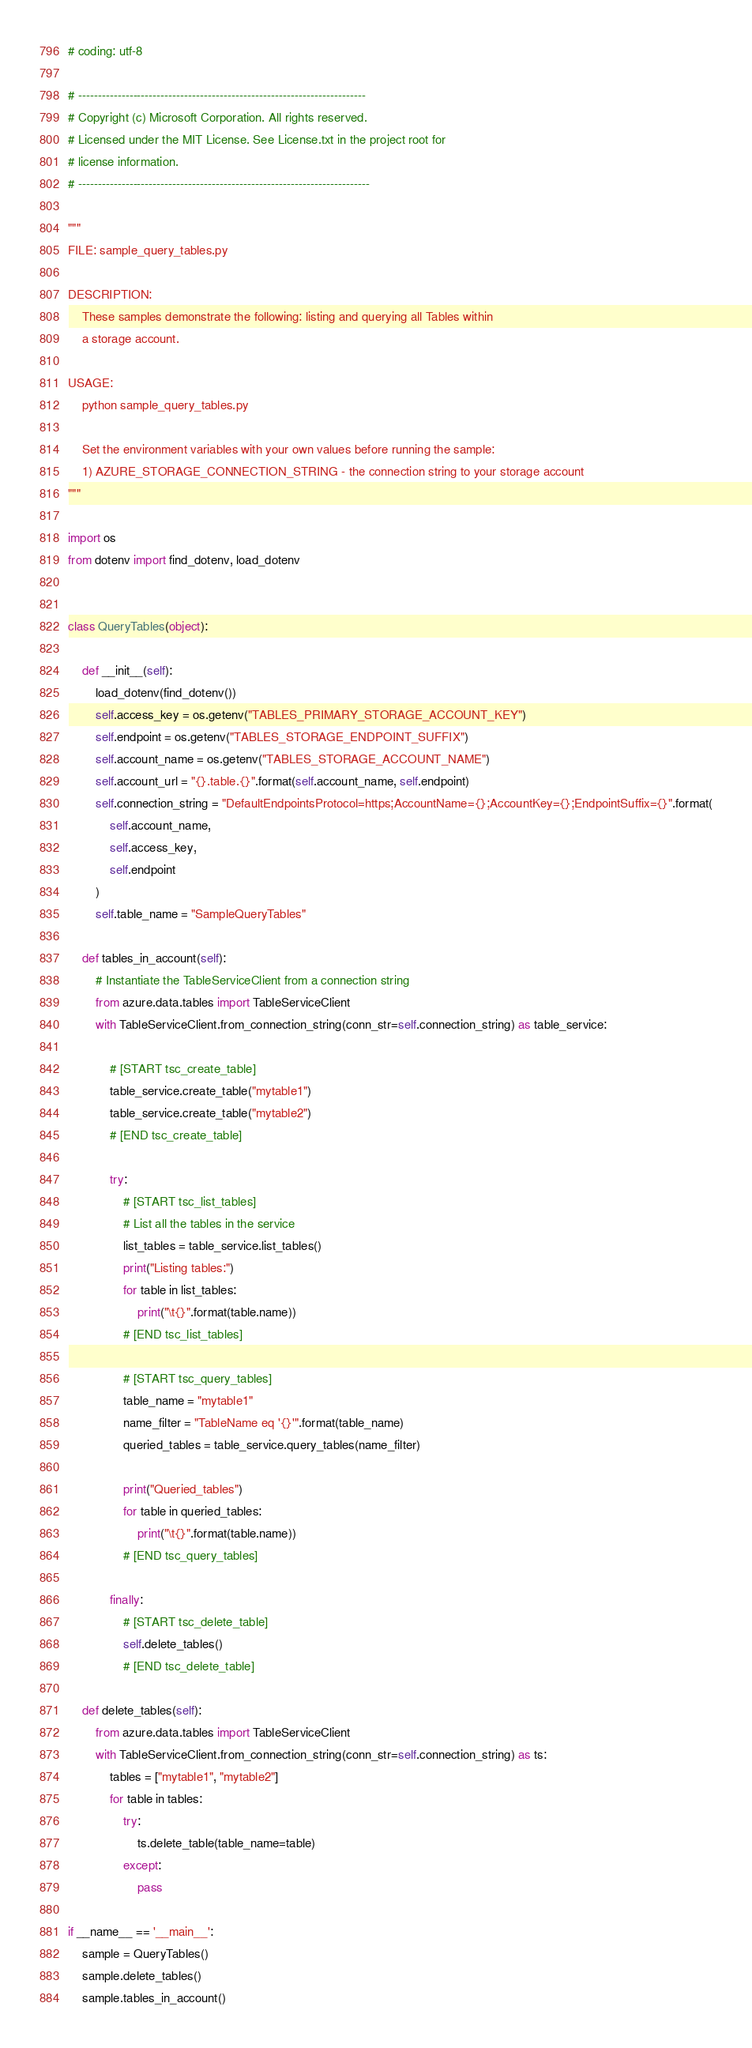Convert code to text. <code><loc_0><loc_0><loc_500><loc_500><_Python_># coding: utf-8

# -------------------------------------------------------------------------
# Copyright (c) Microsoft Corporation. All rights reserved.
# Licensed under the MIT License. See License.txt in the project root for
# license information.
# --------------------------------------------------------------------------

"""
FILE: sample_query_tables.py

DESCRIPTION:
    These samples demonstrate the following: listing and querying all Tables within
    a storage account.

USAGE:
    python sample_query_tables.py

    Set the environment variables with your own values before running the sample:
    1) AZURE_STORAGE_CONNECTION_STRING - the connection string to your storage account
"""

import os
from dotenv import find_dotenv, load_dotenv


class QueryTables(object):

    def __init__(self):
        load_dotenv(find_dotenv())
        self.access_key = os.getenv("TABLES_PRIMARY_STORAGE_ACCOUNT_KEY")
        self.endpoint = os.getenv("TABLES_STORAGE_ENDPOINT_SUFFIX")
        self.account_name = os.getenv("TABLES_STORAGE_ACCOUNT_NAME")
        self.account_url = "{}.table.{}".format(self.account_name, self.endpoint)
        self.connection_string = "DefaultEndpointsProtocol=https;AccountName={};AccountKey={};EndpointSuffix={}".format(
            self.account_name,
            self.access_key,
            self.endpoint
        )
        self.table_name = "SampleQueryTables"

    def tables_in_account(self):
        # Instantiate the TableServiceClient from a connection string
        from azure.data.tables import TableServiceClient
        with TableServiceClient.from_connection_string(conn_str=self.connection_string) as table_service:

            # [START tsc_create_table]
            table_service.create_table("mytable1")
            table_service.create_table("mytable2")
            # [END tsc_create_table]

            try:
                # [START tsc_list_tables]
                # List all the tables in the service
                list_tables = table_service.list_tables()
                print("Listing tables:")
                for table in list_tables:
                    print("\t{}".format(table.name))
                # [END tsc_list_tables]

                # [START tsc_query_tables]
                table_name = "mytable1"
                name_filter = "TableName eq '{}'".format(table_name)
                queried_tables = table_service.query_tables(name_filter)

                print("Queried_tables")
                for table in queried_tables:
                    print("\t{}".format(table.name))
                # [END tsc_query_tables]

            finally:
                # [START tsc_delete_table]
                self.delete_tables()
                # [END tsc_delete_table]

    def delete_tables(self):
        from azure.data.tables import TableServiceClient
        with TableServiceClient.from_connection_string(conn_str=self.connection_string) as ts:
            tables = ["mytable1", "mytable2"]
            for table in tables:
                try:
                    ts.delete_table(table_name=table)
                except:
                    pass

if __name__ == '__main__':
    sample = QueryTables()
    sample.delete_tables()
    sample.tables_in_account()
</code> 